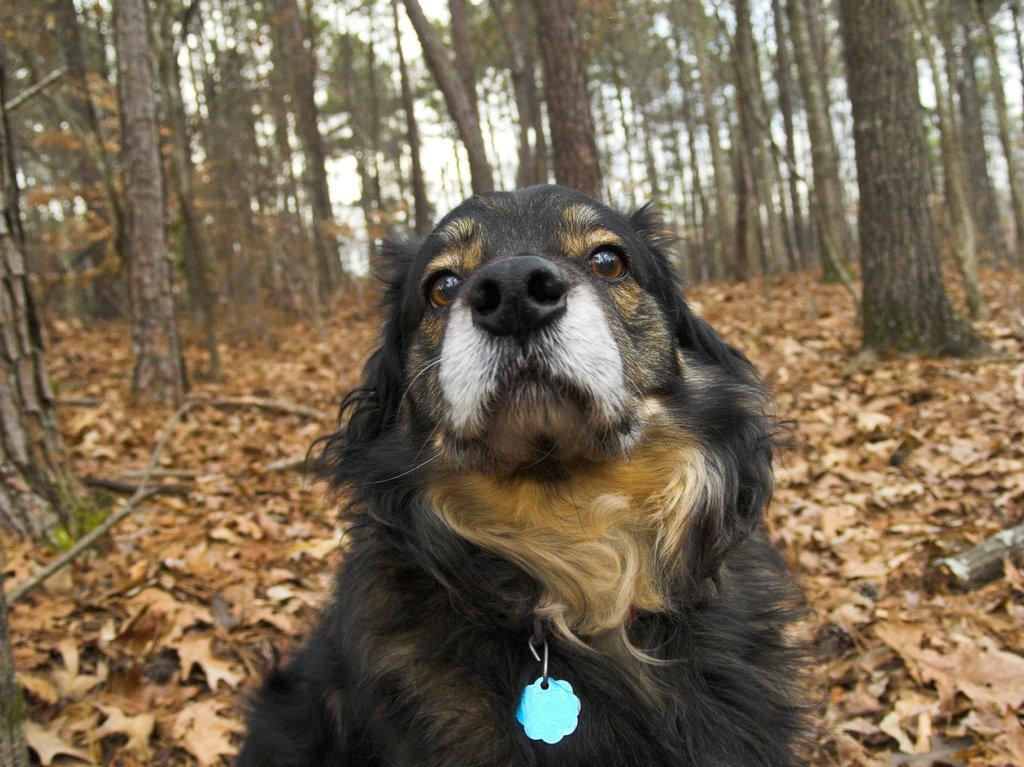What animal is in the picture? There is a donkey in the picture. What is the donkey standing on? The donkey is on dry leaves. What can be seen in the background of the image? There are trees visible in the background of the image, and dry leaves are present as well. What activity is the zebra participating in with the donkey in the image? There is no zebra present in the image, so no such activity can be observed. Where is the faucet located in the image? There is no faucet present in the image. 